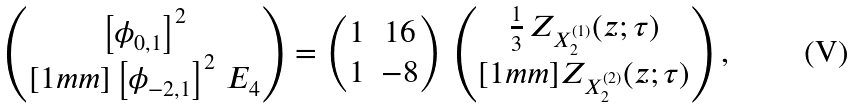<formula> <loc_0><loc_0><loc_500><loc_500>\begin{pmatrix} \left [ \phi _ { 0 , 1 } \right ] ^ { 2 } \\ [ 1 m m ] \left [ \phi _ { - 2 , 1 } \right ] ^ { 2 } \, E _ { 4 } \end{pmatrix} = \begin{pmatrix} 1 & 1 6 \\ 1 & - 8 \end{pmatrix} \, \begin{pmatrix} \frac { 1 } { 3 } \, Z _ { X _ { 2 } ^ { ( 1 ) } } ( z ; \tau ) \\ [ 1 m m ] Z _ { X _ { 2 } ^ { ( 2 ) } } ( z ; \tau ) \end{pmatrix} ,</formula> 